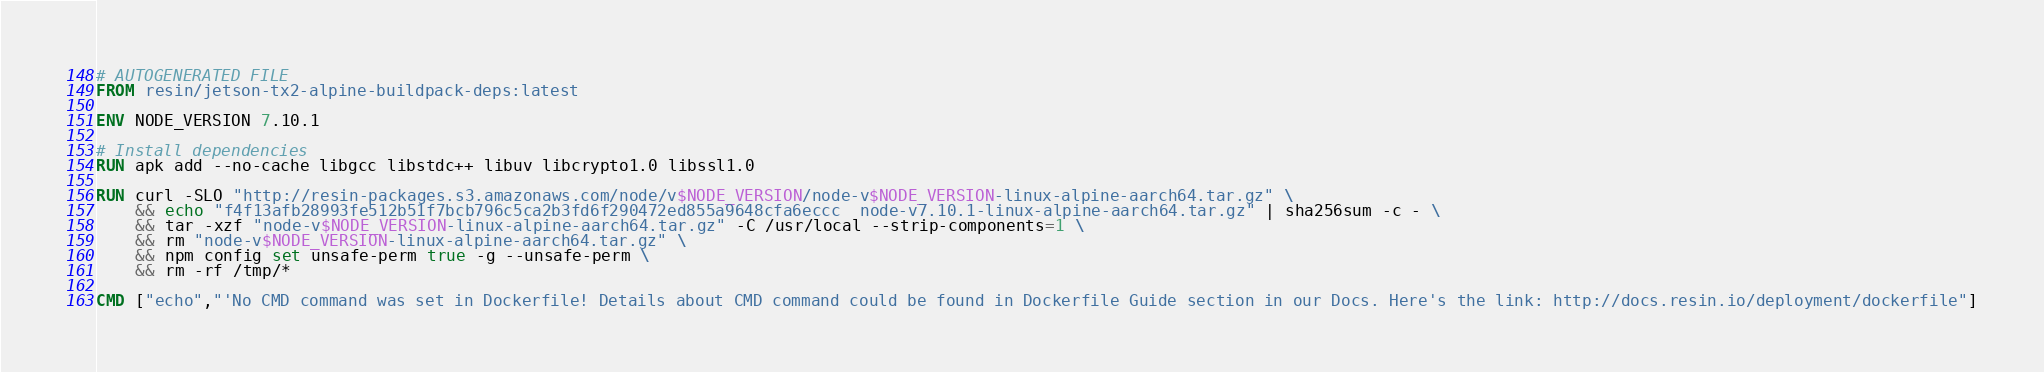<code> <loc_0><loc_0><loc_500><loc_500><_Dockerfile_># AUTOGENERATED FILE
FROM resin/jetson-tx2-alpine-buildpack-deps:latest

ENV NODE_VERSION 7.10.1

# Install dependencies
RUN apk add --no-cache libgcc libstdc++ libuv libcrypto1.0 libssl1.0

RUN curl -SLO "http://resin-packages.s3.amazonaws.com/node/v$NODE_VERSION/node-v$NODE_VERSION-linux-alpine-aarch64.tar.gz" \
	&& echo "f4f13afb28993fe512b51f7bcb796c5ca2b3fd6f290472ed855a9648cfa6eccc  node-v7.10.1-linux-alpine-aarch64.tar.gz" | sha256sum -c - \
	&& tar -xzf "node-v$NODE_VERSION-linux-alpine-aarch64.tar.gz" -C /usr/local --strip-components=1 \
	&& rm "node-v$NODE_VERSION-linux-alpine-aarch64.tar.gz" \
	&& npm config set unsafe-perm true -g --unsafe-perm \
	&& rm -rf /tmp/*

CMD ["echo","'No CMD command was set in Dockerfile! Details about CMD command could be found in Dockerfile Guide section in our Docs. Here's the link: http://docs.resin.io/deployment/dockerfile"]
</code> 